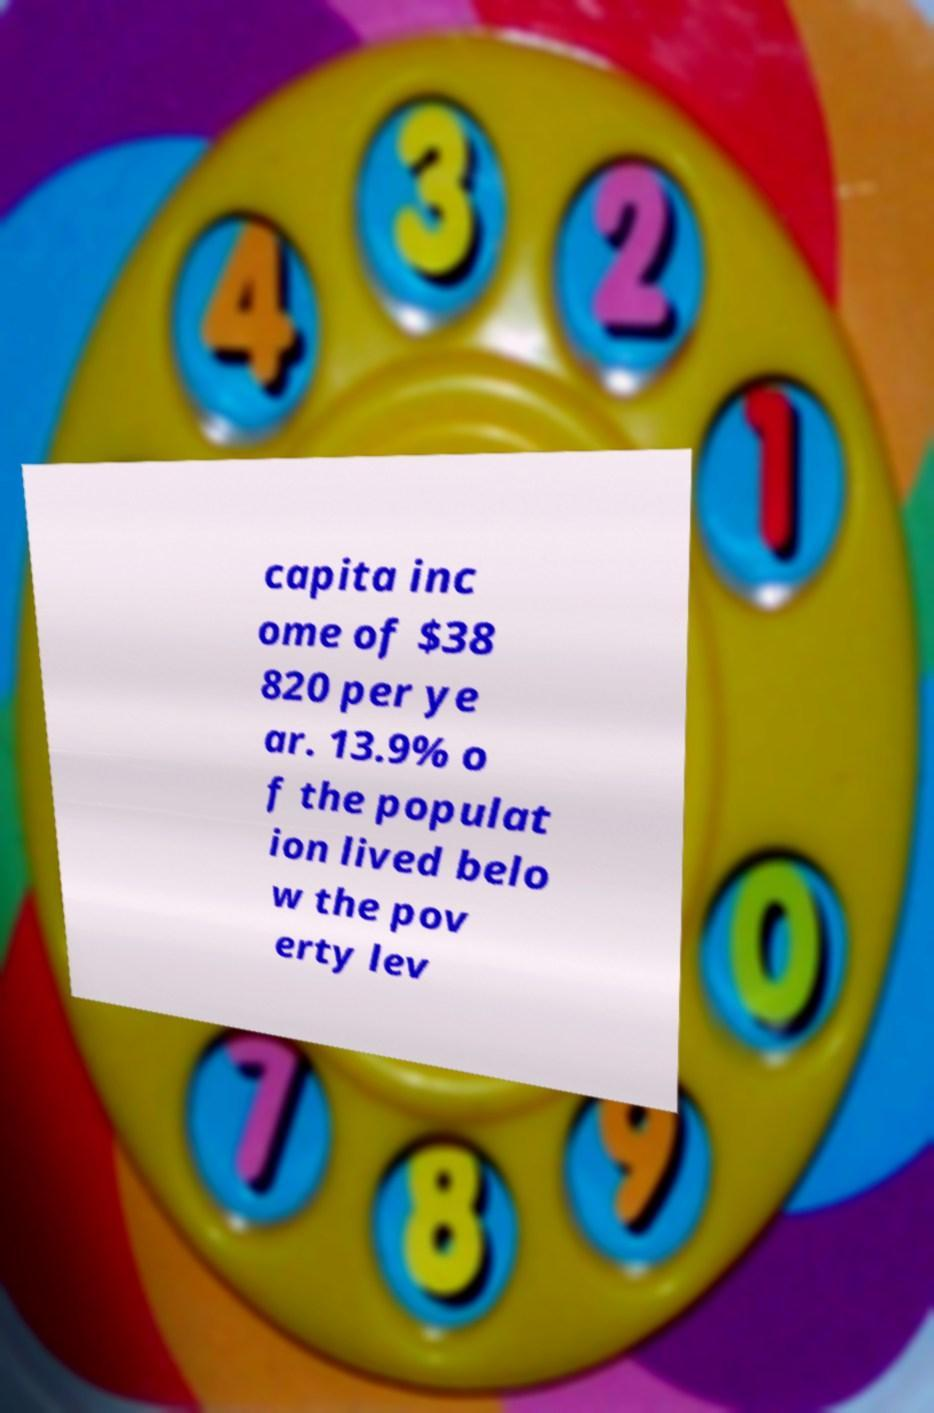I need the written content from this picture converted into text. Can you do that? capita inc ome of $38 820 per ye ar. 13.9% o f the populat ion lived belo w the pov erty lev 